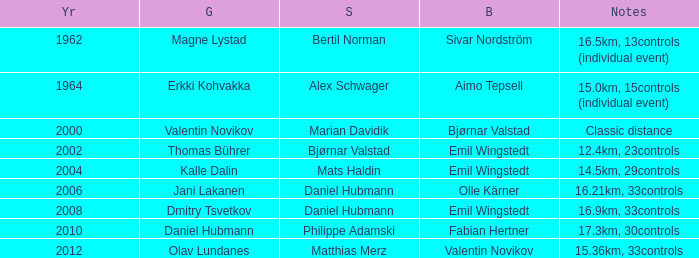WHAT YEAR HAS A BRONZE OF VALENTIN NOVIKOV? 2012.0. 